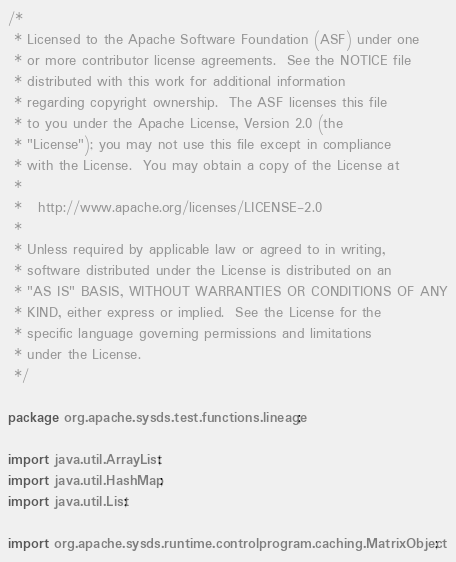Convert code to text. <code><loc_0><loc_0><loc_500><loc_500><_Java_>/*
 * Licensed to the Apache Software Foundation (ASF) under one
 * or more contributor license agreements.  See the NOTICE file
 * distributed with this work for additional information
 * regarding copyright ownership.  The ASF licenses this file
 * to you under the Apache License, Version 2.0 (the
 * "License"); you may not use this file except in compliance
 * with the License.  You may obtain a copy of the License at
 *
 *   http://www.apache.org/licenses/LICENSE-2.0
 *
 * Unless required by applicable law or agreed to in writing,
 * software distributed under the License is distributed on an
 * "AS IS" BASIS, WITHOUT WARRANTIES OR CONDITIONS OF ANY
 * KIND, either express or implied.  See the License for the
 * specific language governing permissions and limitations
 * under the License.
 */

package org.apache.sysds.test.functions.lineage;

import java.util.ArrayList;
import java.util.HashMap;
import java.util.List;

import org.apache.sysds.runtime.controlprogram.caching.MatrixObject;</code> 